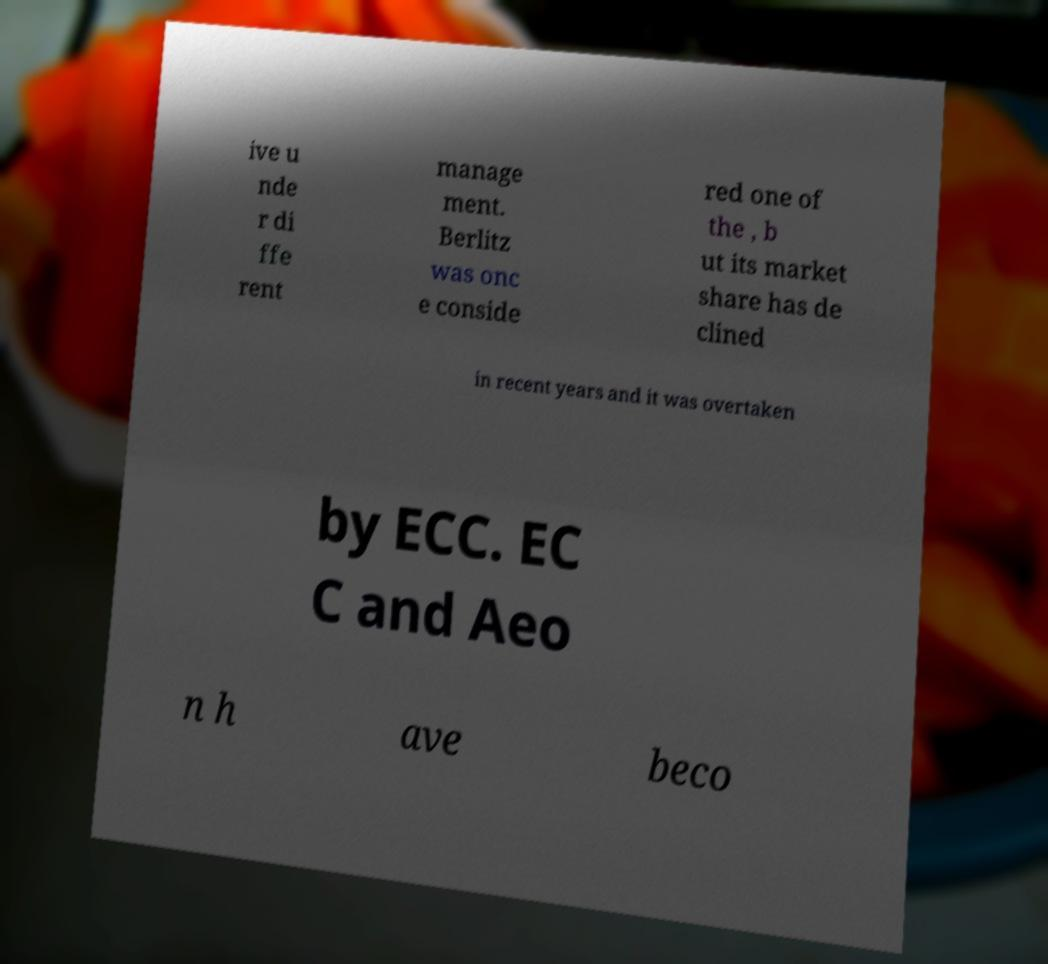Could you assist in decoding the text presented in this image and type it out clearly? ive u nde r di ffe rent manage ment. Berlitz was onc e conside red one of the , b ut its market share has de clined in recent years and it was overtaken by ECC. EC C and Aeo n h ave beco 